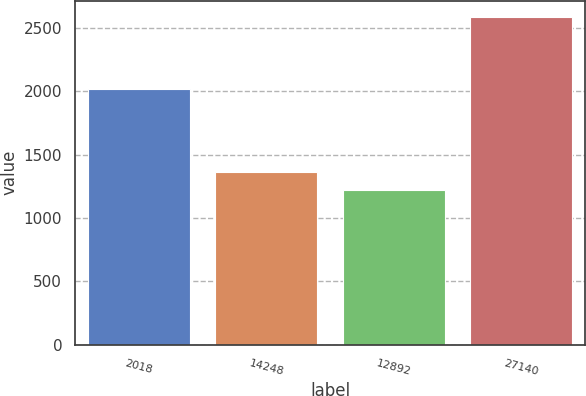Convert chart to OTSL. <chart><loc_0><loc_0><loc_500><loc_500><bar_chart><fcel>2018<fcel>14248<fcel>12892<fcel>27140<nl><fcel>2017<fcel>1359.5<fcel>1223.4<fcel>2582.9<nl></chart> 